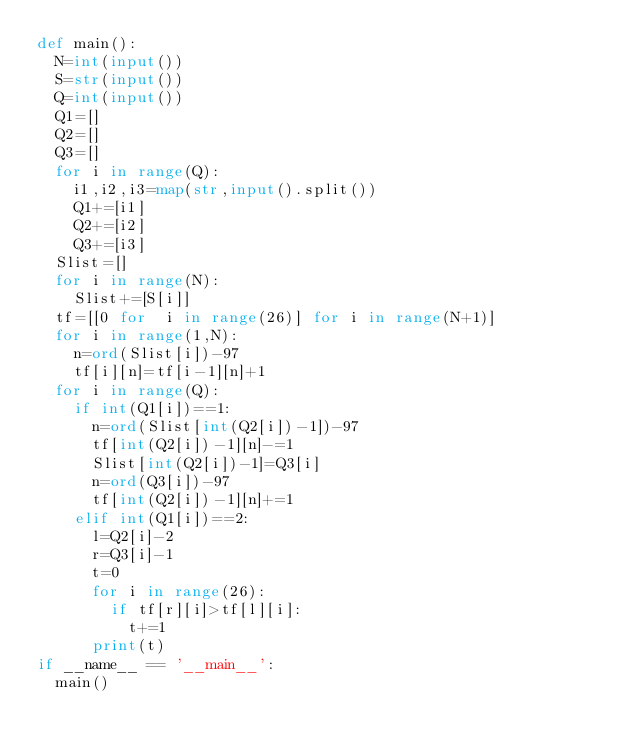<code> <loc_0><loc_0><loc_500><loc_500><_Python_>def main():
  N=int(input())
  S=str(input())
  Q=int(input())
  Q1=[]
  Q2=[]
  Q3=[]
  for i in range(Q):
    i1,i2,i3=map(str,input().split())
    Q1+=[i1]
    Q2+=[i2]
    Q3+=[i3]
  Slist=[]
  for i in range(N):
    Slist+=[S[i]]
  tf=[[0 for  i in range(26)] for i in range(N+1)]
  for i in range(1,N):
    n=ord(Slist[i])-97
    tf[i][n]=tf[i-1][n]+1
  for i in range(Q):
    if int(Q1[i])==1:
      n=ord(Slist[int(Q2[i])-1])-97
      tf[int(Q2[i])-1][n]-=1
      Slist[int(Q2[i])-1]=Q3[i]
      n=ord(Q3[i])-97
      tf[int(Q2[i])-1][n]+=1
    elif int(Q1[i])==2:
      l=Q2[i]-2
      r=Q3[i]-1
      t=0
      for i in range(26):
        if tf[r][i]>tf[l][i]:
          t+=1
      print(t)
if __name__ == '__main__':
  main()
</code> 